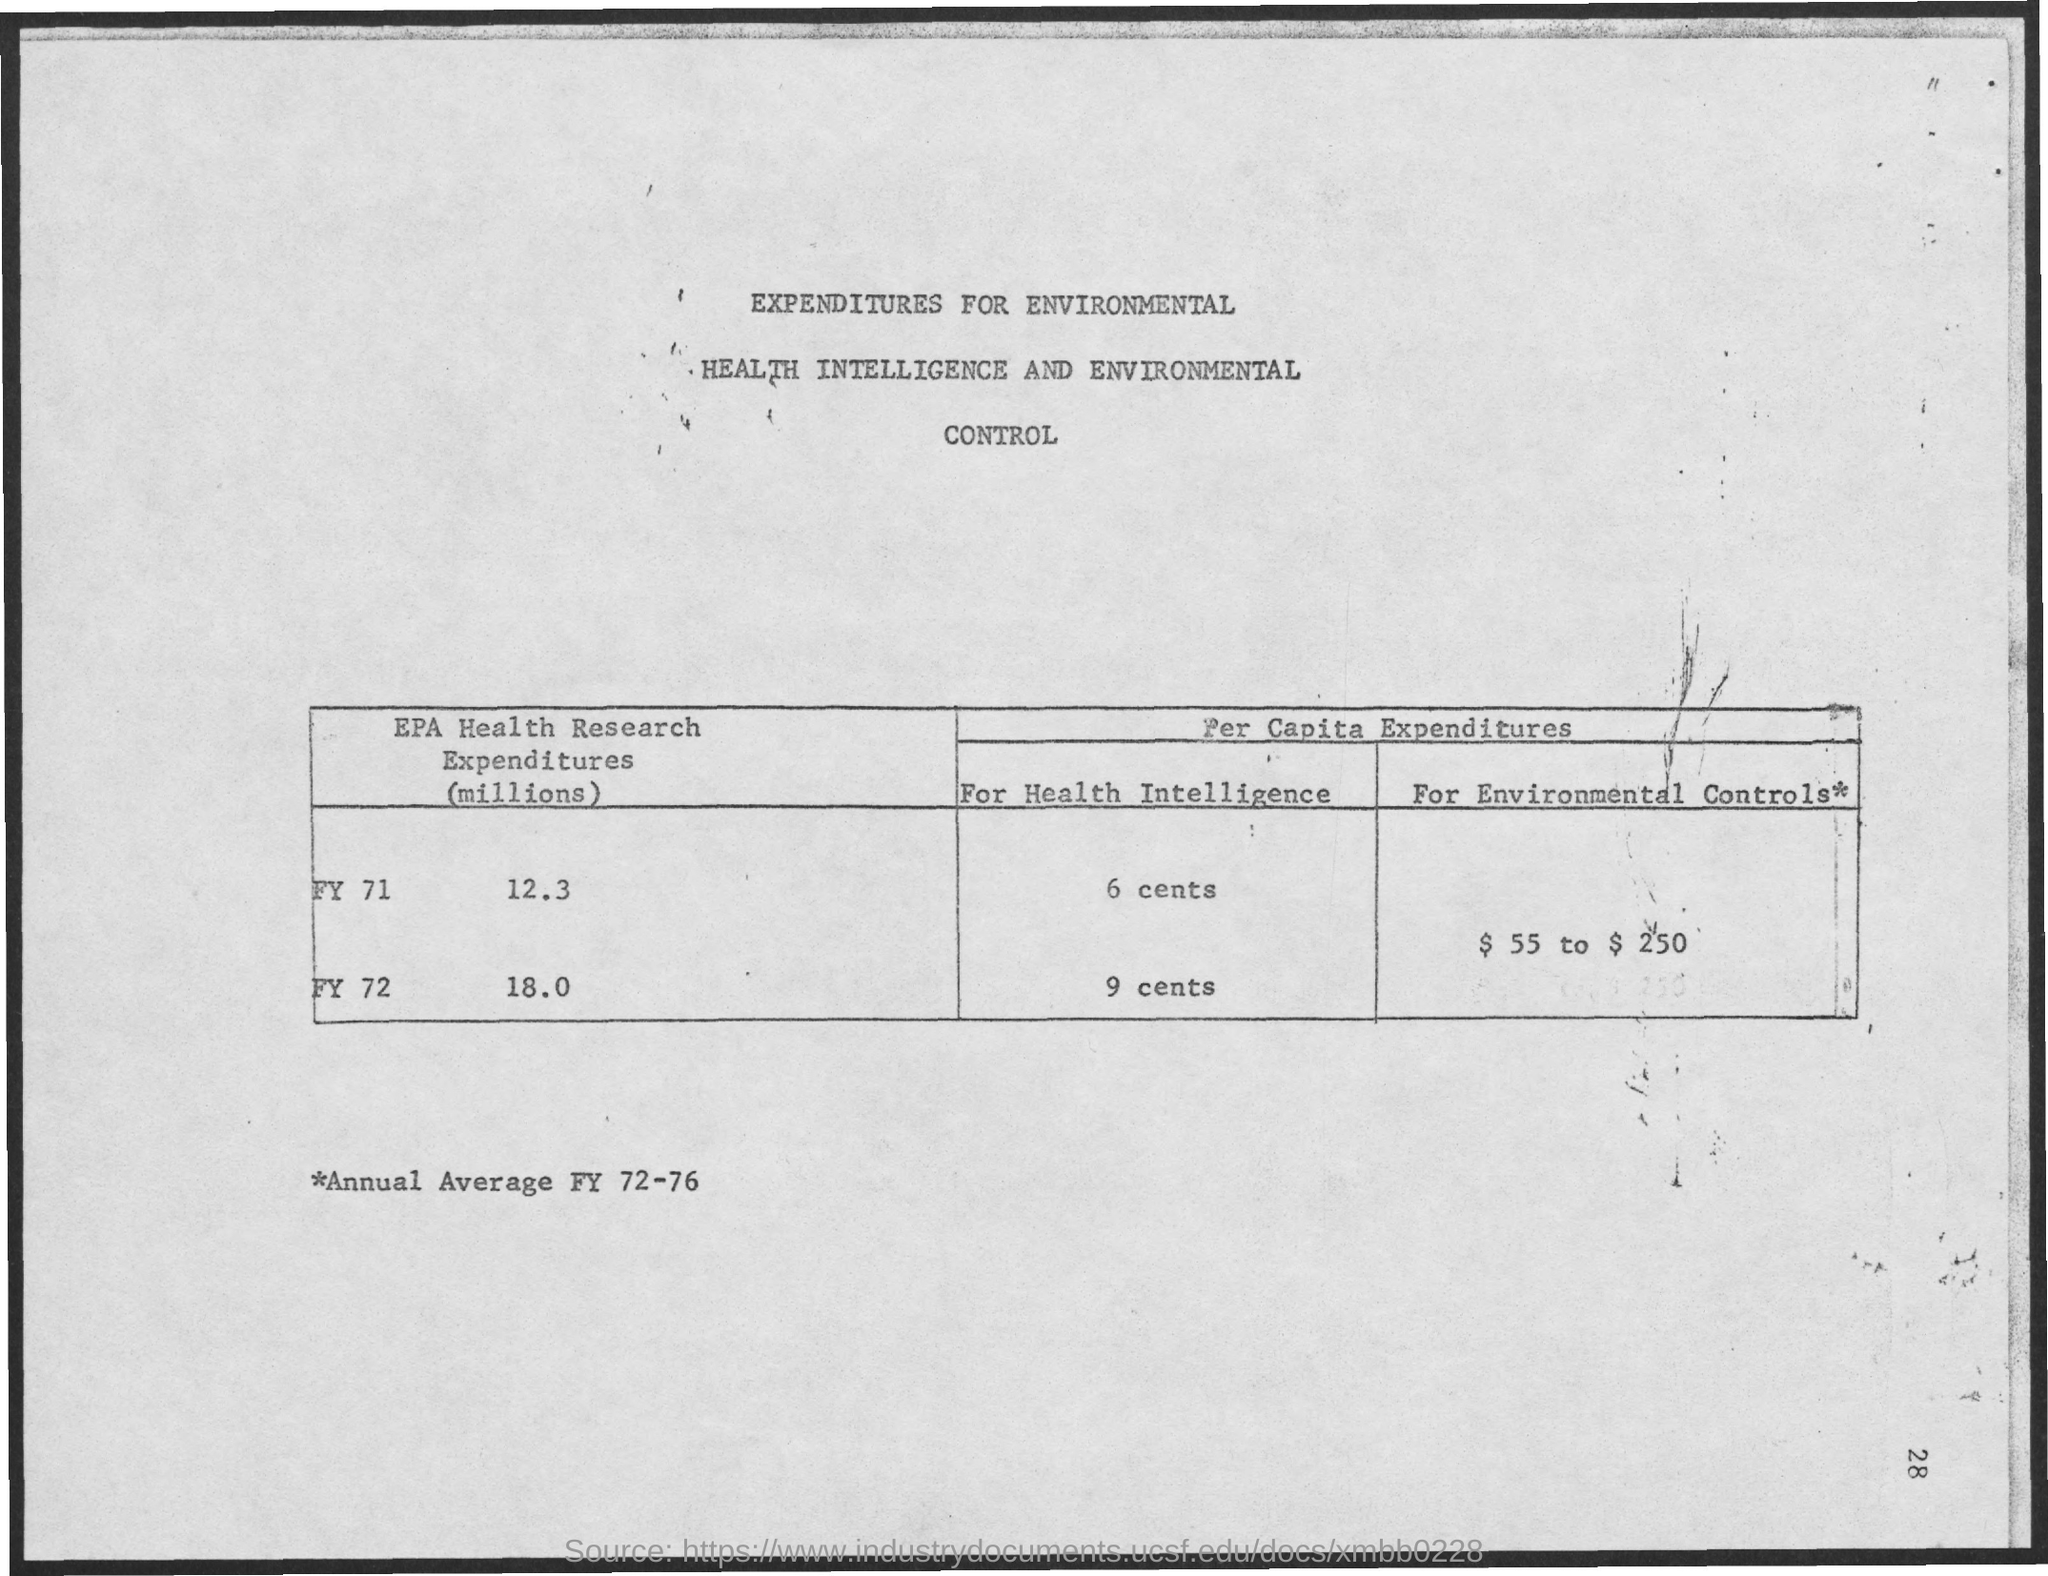What is the title of the document?
Offer a very short reply. Expenditures for environmental health intelligence and environmental control. 